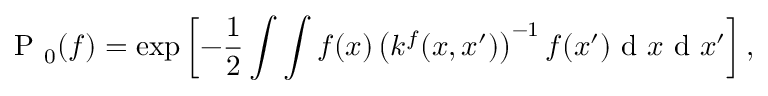<formula> <loc_0><loc_0><loc_500><loc_500>P _ { 0 } ( { f } ) = \exp \left [ - \frac { 1 } { 2 } \int \int f ( x ) \left ( k ^ { f } ( x , x ^ { \prime } ) \right ) ^ { - 1 } f ( x ^ { \prime } ) d x d x ^ { \prime } \right ] ,</formula> 